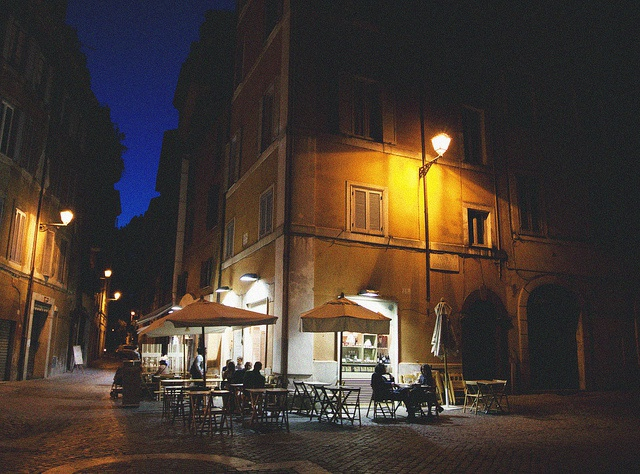Describe the objects in this image and their specific colors. I can see umbrella in black, brown, and maroon tones, umbrella in black, gray, brown, and maroon tones, umbrella in black, maroon, olive, and gray tones, chair in black, gray, and darkgray tones, and chair in black and gray tones in this image. 